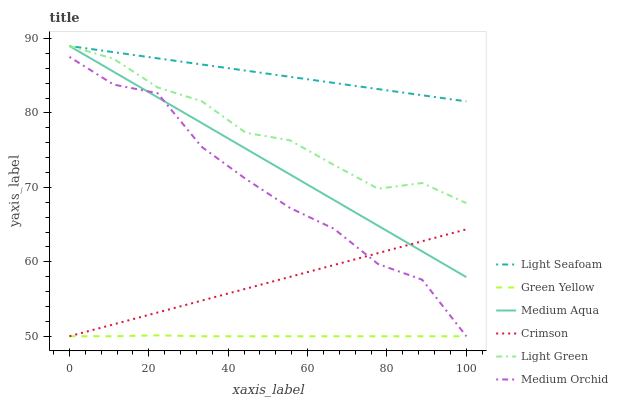Does Green Yellow have the minimum area under the curve?
Answer yes or no. Yes. Does Light Seafoam have the maximum area under the curve?
Answer yes or no. Yes. Does Medium Orchid have the minimum area under the curve?
Answer yes or no. No. Does Medium Orchid have the maximum area under the curve?
Answer yes or no. No. Is Crimson the smoothest?
Answer yes or no. Yes. Is Medium Orchid the roughest?
Answer yes or no. Yes. Is Medium Aqua the smoothest?
Answer yes or no. No. Is Medium Aqua the roughest?
Answer yes or no. No. Does Medium Orchid have the lowest value?
Answer yes or no. Yes. Does Medium Aqua have the lowest value?
Answer yes or no. No. Does Light Green have the highest value?
Answer yes or no. Yes. Does Medium Orchid have the highest value?
Answer yes or no. No. Is Green Yellow less than Medium Aqua?
Answer yes or no. Yes. Is Light Seafoam greater than Crimson?
Answer yes or no. Yes. Does Medium Orchid intersect Medium Aqua?
Answer yes or no. Yes. Is Medium Orchid less than Medium Aqua?
Answer yes or no. No. Is Medium Orchid greater than Medium Aqua?
Answer yes or no. No. Does Green Yellow intersect Medium Aqua?
Answer yes or no. No. 